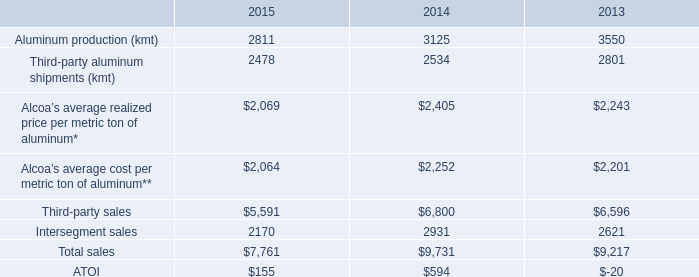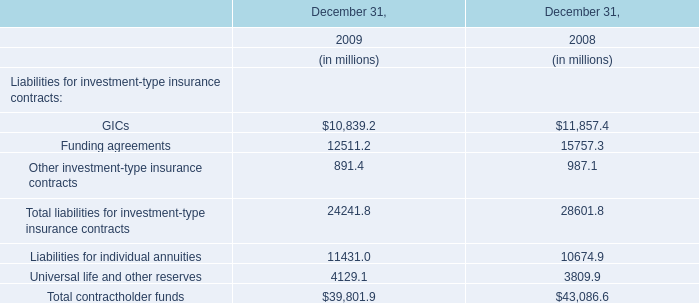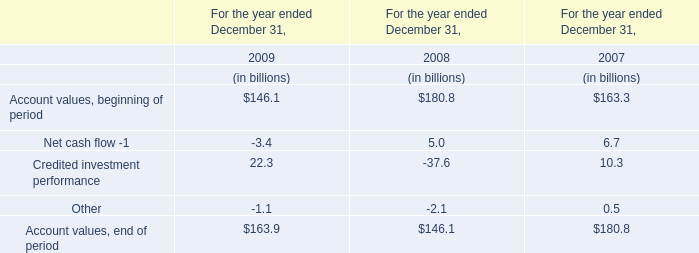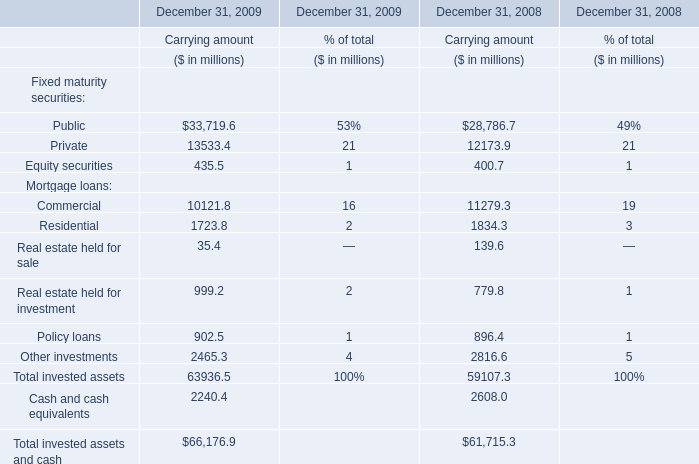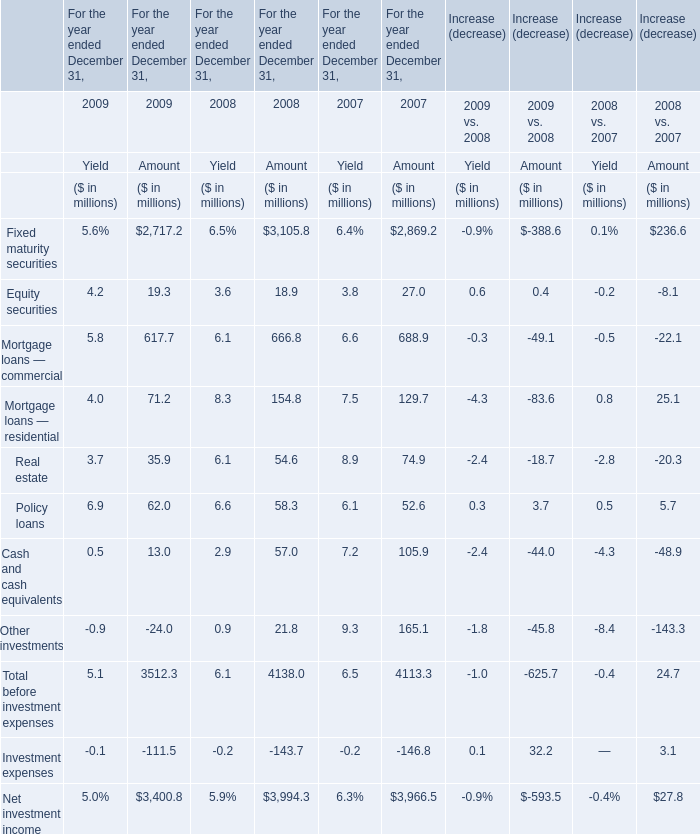Which year for yield is Mortgage loans — residential the highest? 
Answer: 2008. 